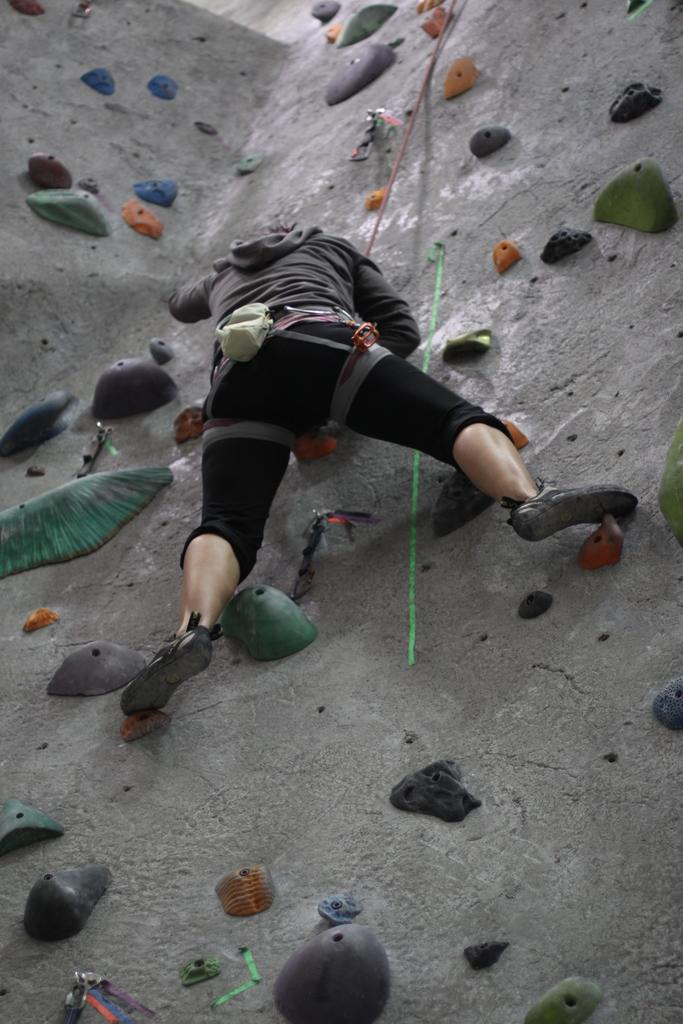What is the person in the image doing? The person is climbing on a rock. What is the person using to assist with the climb? The person is holding a rope. What type of step is the person using to climb the rock in the image? There is no mention of a step in the image; the person is using a rope to assist with the climb. Is there a servant present in the image to help the person climb the rock? There is no mention of a servant in the image; the person is climbing the rock with the assistance of a rope. 